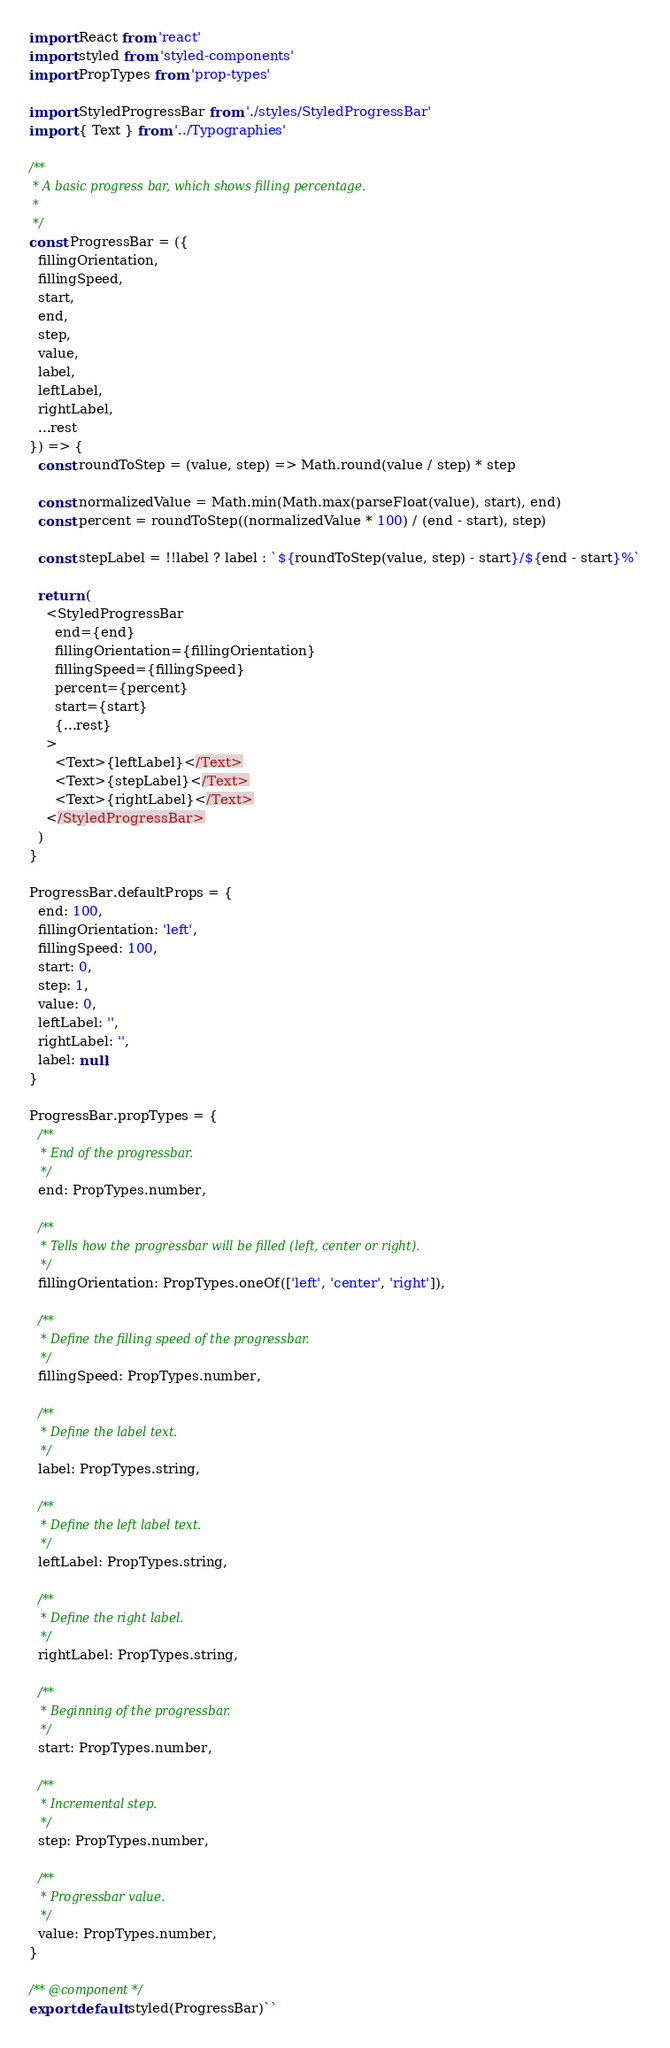<code> <loc_0><loc_0><loc_500><loc_500><_JavaScript_>import React from 'react'
import styled from 'styled-components'
import PropTypes from 'prop-types'

import StyledProgressBar from './styles/StyledProgressBar'
import { Text } from '../Typographies'

/**
 * A basic progress bar, which shows filling percentage.
 *
 */
const ProgressBar = ({
  fillingOrientation,
  fillingSpeed,
  start,
  end,
  step,
  value,
  label,
  leftLabel,
  rightLabel,
  ...rest
}) => {
  const roundToStep = (value, step) => Math.round(value / step) * step

  const normalizedValue = Math.min(Math.max(parseFloat(value), start), end)
  const percent = roundToStep((normalizedValue * 100) / (end - start), step)

  const stepLabel = !!label ? label : `${roundToStep(value, step) - start}/${end - start}%`

  return (
    <StyledProgressBar
      end={end}
      fillingOrientation={fillingOrientation}
      fillingSpeed={fillingSpeed}
      percent={percent}
      start={start}
      {...rest}
    >
      <Text>{leftLabel}</Text>
      <Text>{stepLabel}</Text>
      <Text>{rightLabel}</Text>
    </StyledProgressBar>
  )
}

ProgressBar.defaultProps = {
  end: 100,
  fillingOrientation: 'left',
  fillingSpeed: 100,
  start: 0,
  step: 1,
  value: 0,
  leftLabel: '',
  rightLabel: '',
  label: null,
}

ProgressBar.propTypes = {
  /**
   * End of the progressbar.
   */
  end: PropTypes.number,

  /**
   * Tells how the progressbar will be filled (left, center or right).
   */
  fillingOrientation: PropTypes.oneOf(['left', 'center', 'right']),

  /**
   * Define the filling speed of the progressbar.
   */
  fillingSpeed: PropTypes.number,

  /**
   * Define the label text.
   */
  label: PropTypes.string,

  /**
   * Define the left label text.
   */
  leftLabel: PropTypes.string,

  /**
   * Define the right label.
   */
  rightLabel: PropTypes.string,

  /**
   * Beginning of the progressbar.
   */
  start: PropTypes.number,

  /**
   * Incremental step.
   */
  step: PropTypes.number,

  /**
   * Progressbar value.
   */
  value: PropTypes.number,
}

/** @component */
export default styled(ProgressBar)``
</code> 